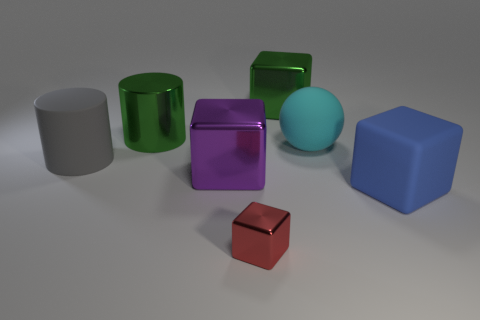Add 2 cyan things. How many objects exist? 9 Subtract all spheres. How many objects are left? 6 Add 3 rubber things. How many rubber things are left? 6 Add 3 tiny things. How many tiny things exist? 4 Subtract 0 purple cylinders. How many objects are left? 7 Subtract all gray things. Subtract all large yellow rubber cylinders. How many objects are left? 6 